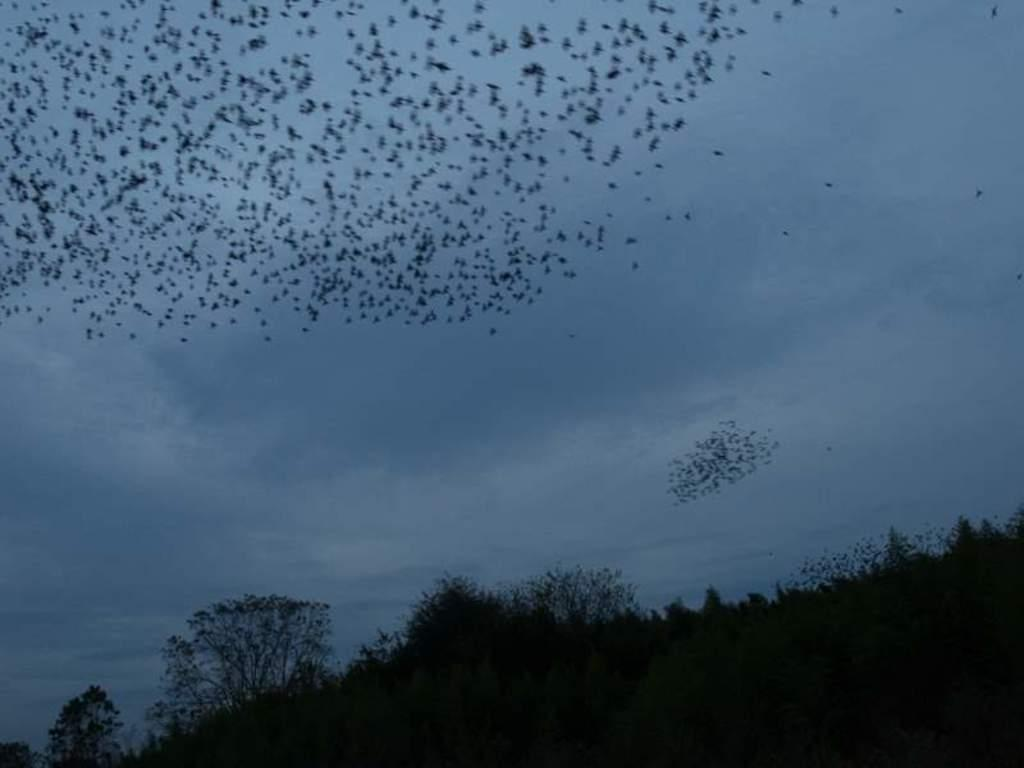What type of vegetation is at the bottom of the image? There are trees at the bottom of the image. What animals can be seen in the image? Birds are flying in the image. What part of the natural environment is visible in the image? The sky is visible in the image. What type of powder can be seen covering the trees in the image? There is no powder visible in the image; the trees are not covered in any substance. What type of lace is draped over the birds in the image? There is no lace present in the image; the birds are not wearing or carrying any fabric. 